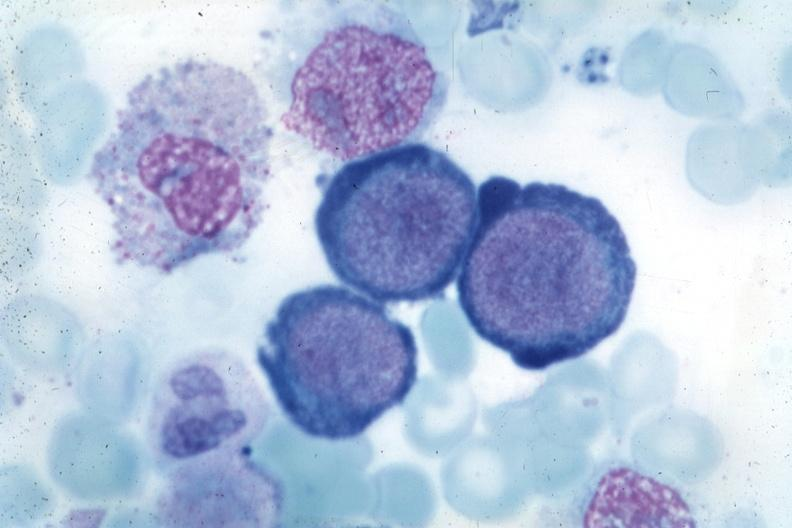s hemorrhagic corpus luteum present?
Answer the question using a single word or phrase. No 